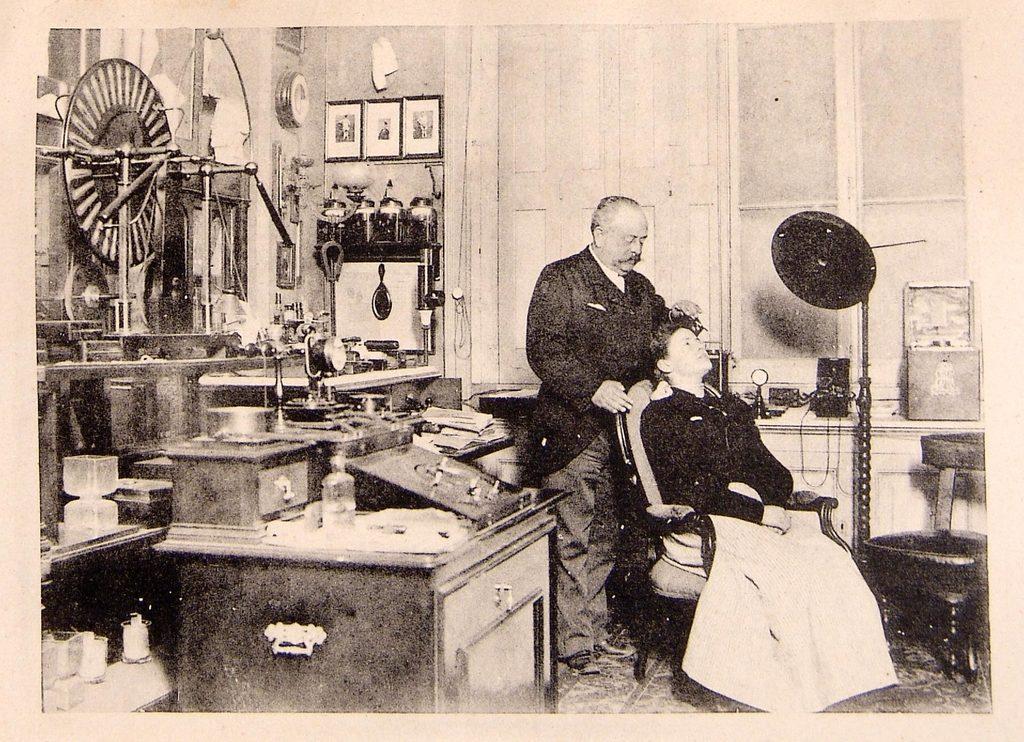In one or two sentences, can you explain what this image depicts? This is a black and white image in this image there is one person who is standing in front of there is one chair, on the chair there is another person who is sitting and on the left side there is a table boxes and some other instruments are there and also there are some photo frames on the wall. In the background there is a wall and on the right side there is a stool and some lights. 